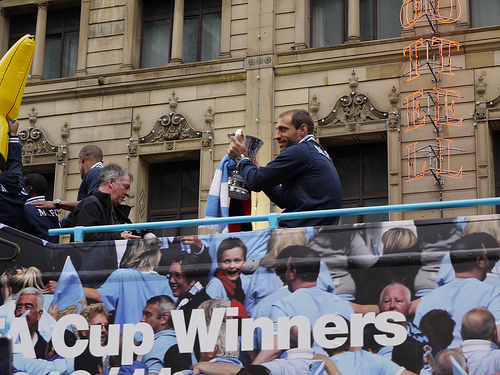<image>
Can you confirm if the trophy is on the bus? Yes. Looking at the image, I can see the trophy is positioned on top of the bus, with the bus providing support. 